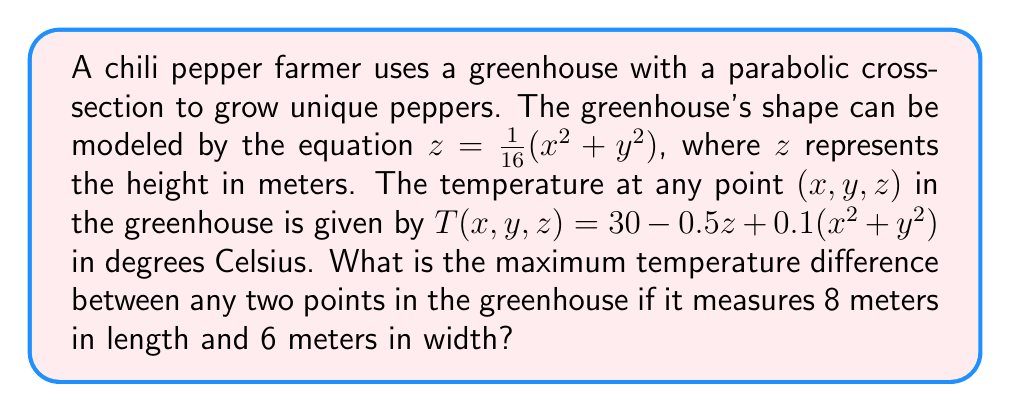Teach me how to tackle this problem. Let's approach this step-by-step:

1) First, we need to find the range of $z$ values:
   At the edges of the greenhouse, $x = \pm 4$ and $y = \pm 3$
   Maximum $z$ occurs at the corners: $z_{max} = \frac{1}{16}(4^2 + 3^2) = \frac{25}{16} = 1.5625$ m
   Minimum $z$ is at the center: $z_{min} = 0$ m

2) Now, let's express the temperature in terms of $x$ and $y$ only:
   $T(x, y) = 30 - 0.5(\frac{1}{16}(x^2 + y^2)) + 0.1(x^2 + y^2)$
   $T(x, y) = 30 - \frac{1}{32}(x^2 + y^2) + 0.1(x^2 + y^2)$
   $T(x, y) = 30 + (\frac{26}{32})(x^2 + y^2)$

3) The maximum temperature will occur at the corners where $x^2 + y^2$ is largest:
   $T_{max} = 30 + (\frac{26}{32})(4^2 + 3^2) = 30 + (\frac{26}{32})(25) = 50.3125$ °C

4) The minimum temperature will occur at the center where $x = y = 0$:
   $T_{min} = 30$ °C

5) The maximum temperature difference is:
   $\Delta T = T_{max} - T_{min} = 50.3125 - 30 = 20.3125$ °C
Answer: 20.3125 °C 